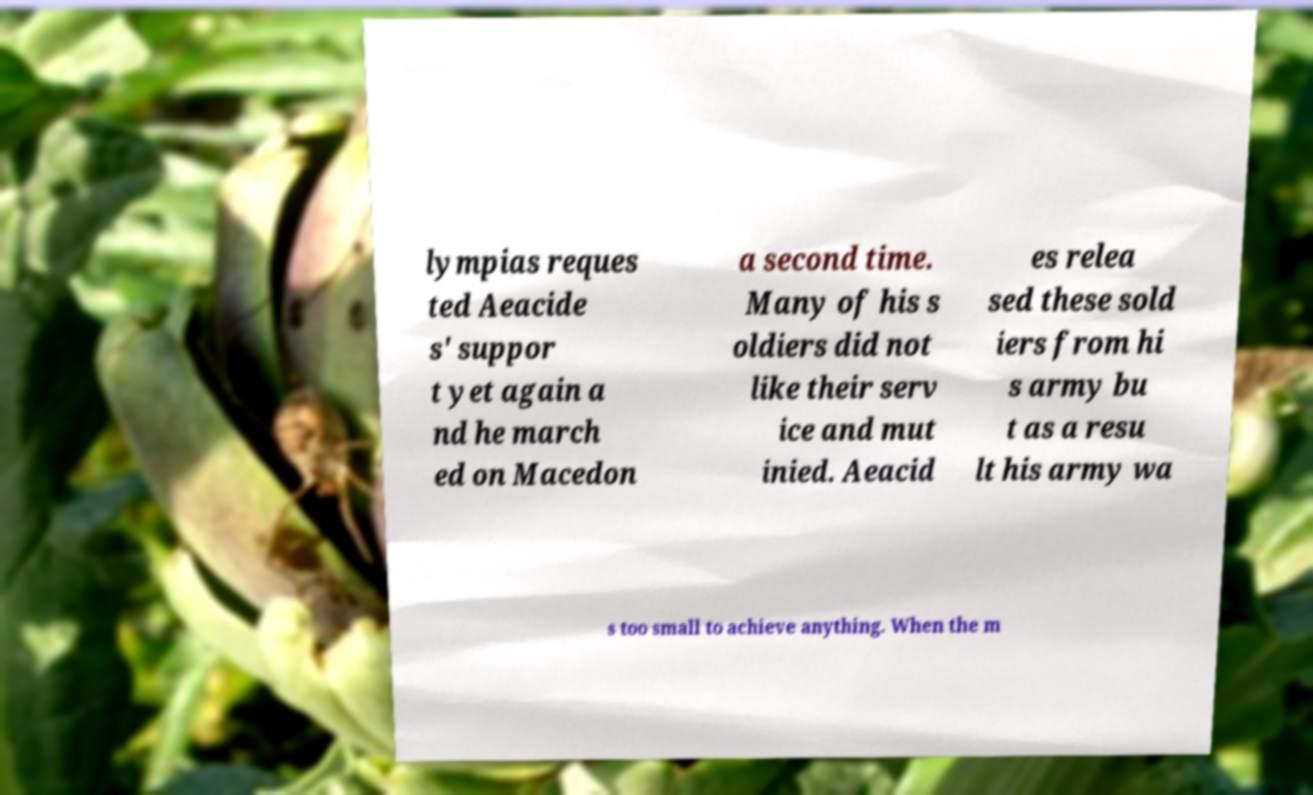Could you assist in decoding the text presented in this image and type it out clearly? lympias reques ted Aeacide s' suppor t yet again a nd he march ed on Macedon a second time. Many of his s oldiers did not like their serv ice and mut inied. Aeacid es relea sed these sold iers from hi s army bu t as a resu lt his army wa s too small to achieve anything. When the m 